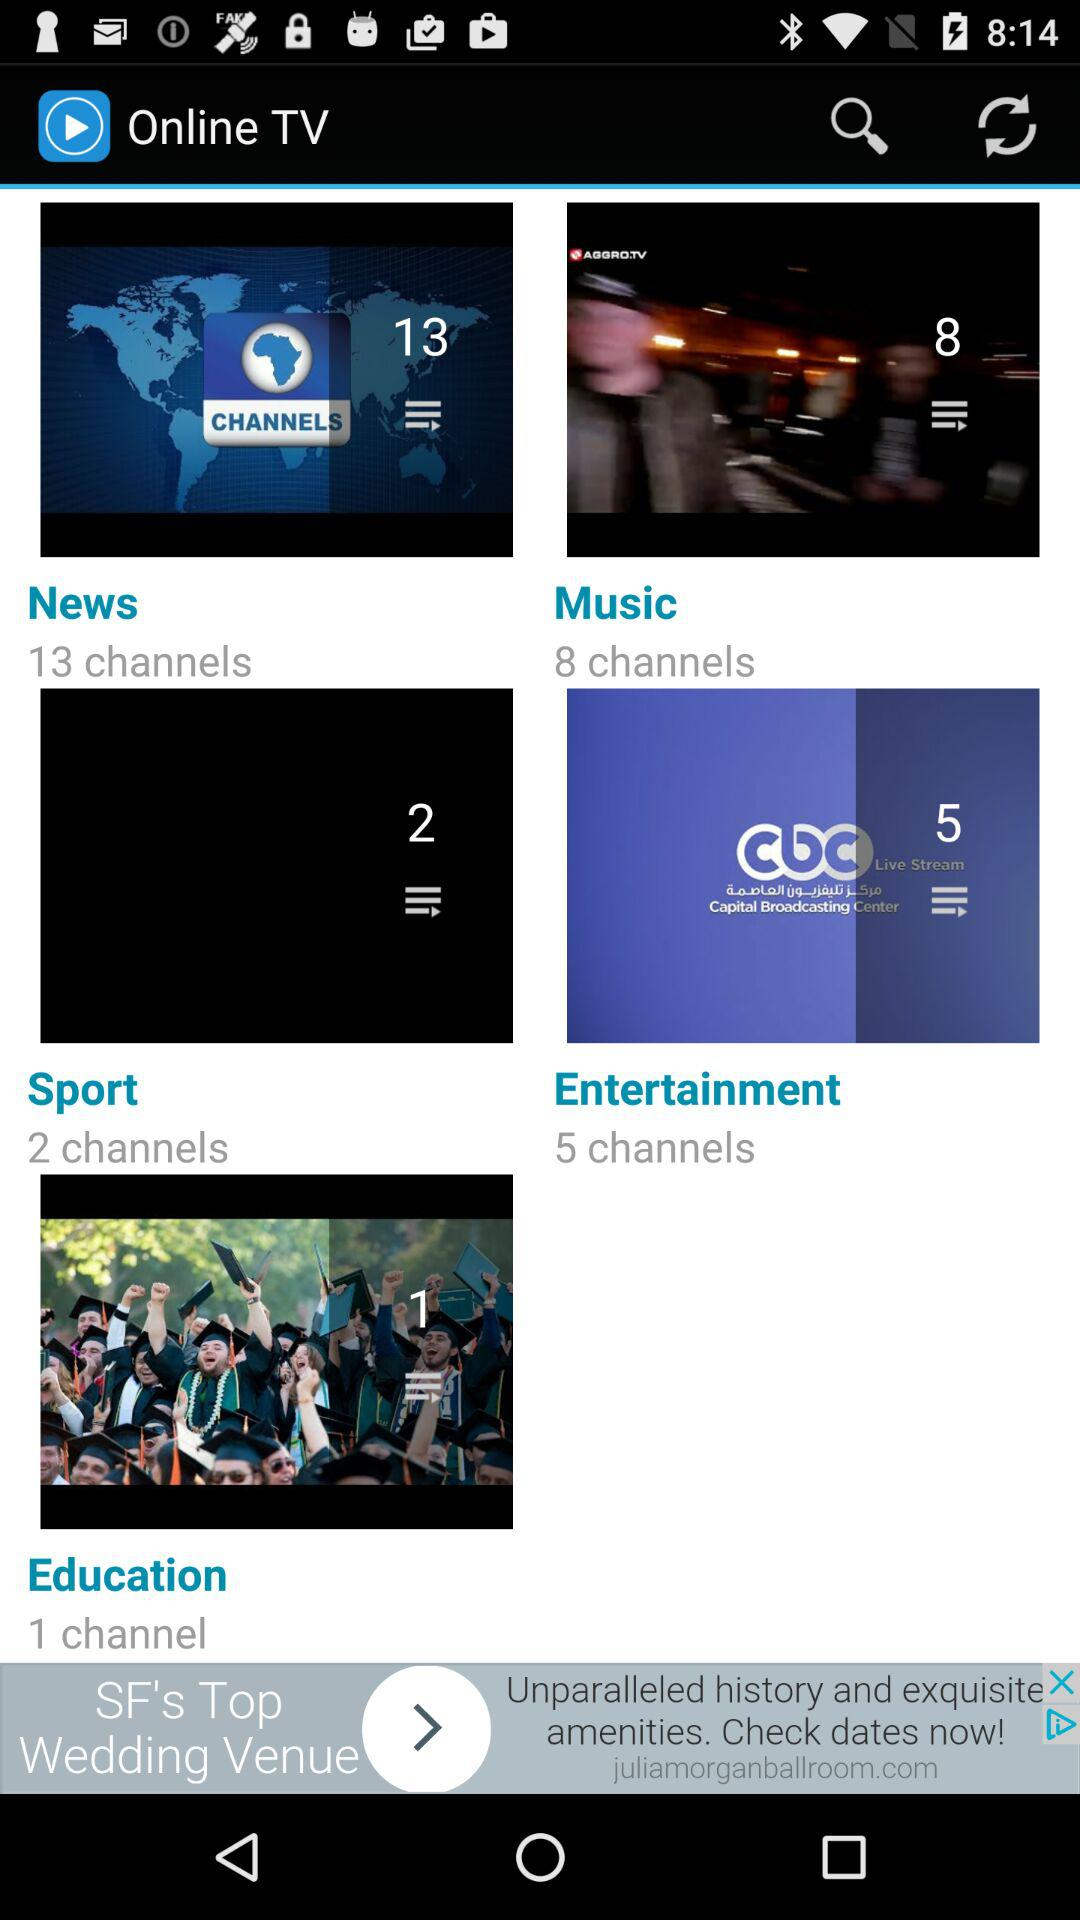What is the number of music channels? The number of music channels is 8. 